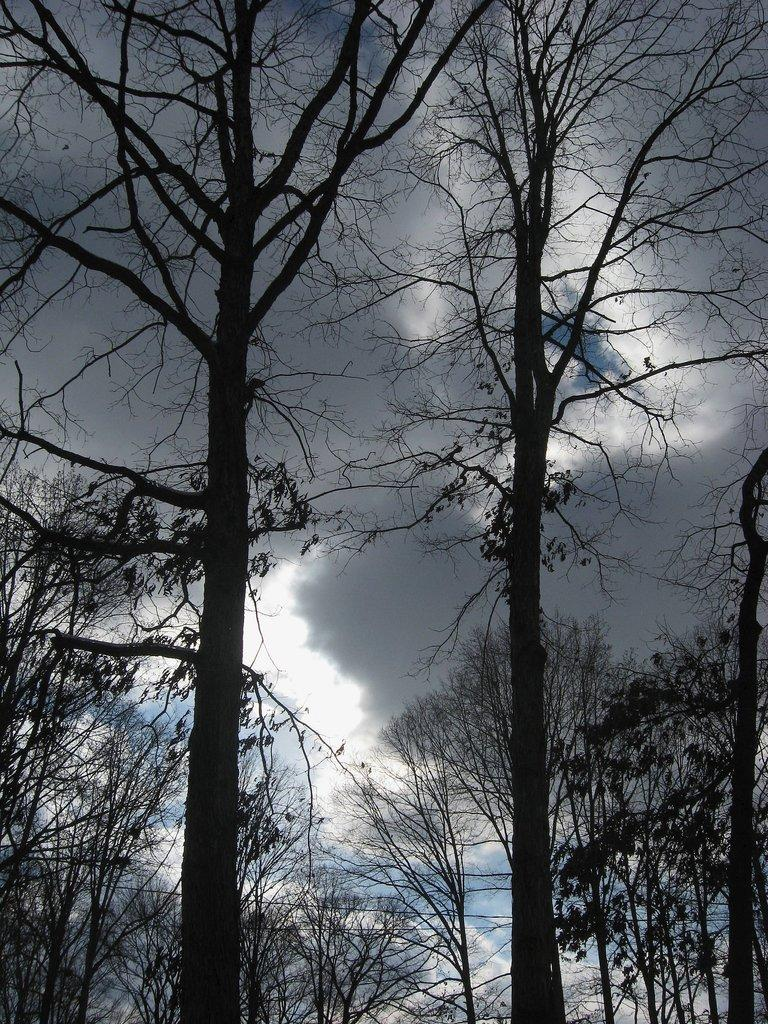What is the primary feature of the image? There are many trees in the image. What can be seen in the background of the image? There are clouds and the sky visible in the background of the image. What type of jam is being spread on the rail in the image? There is no jam or rail present in the image; it features trees and a sky background. 